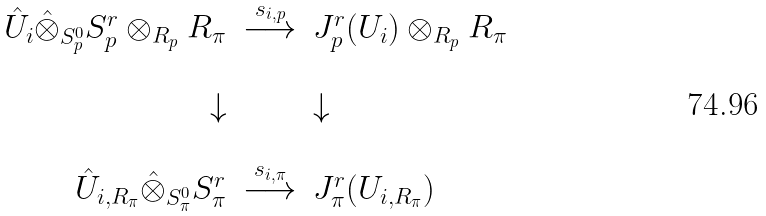<formula> <loc_0><loc_0><loc_500><loc_500>\begin{array} { r c l } \hat { U } _ { i } \hat { \otimes } _ { S _ { p } ^ { 0 } } S _ { p } ^ { r } \otimes _ { R _ { p } } R _ { \pi } & \stackrel { s _ { i , p } } { \longrightarrow } & J _ { p } ^ { r } ( U _ { i } ) \otimes _ { R _ { p } } R _ { \pi } \\ \ & \ & \ \\ \downarrow & \ & \downarrow \\ \ & \ & \ \\ \hat { U } _ { i , R _ { \pi } } \hat { \otimes } _ { S _ { \pi } ^ { 0 } } S _ { \pi } ^ { r } & \stackrel { s _ { i , \pi } } { \longrightarrow } & J ^ { r } _ { \pi } ( U _ { i , R _ { \pi } } ) \end{array}</formula> 